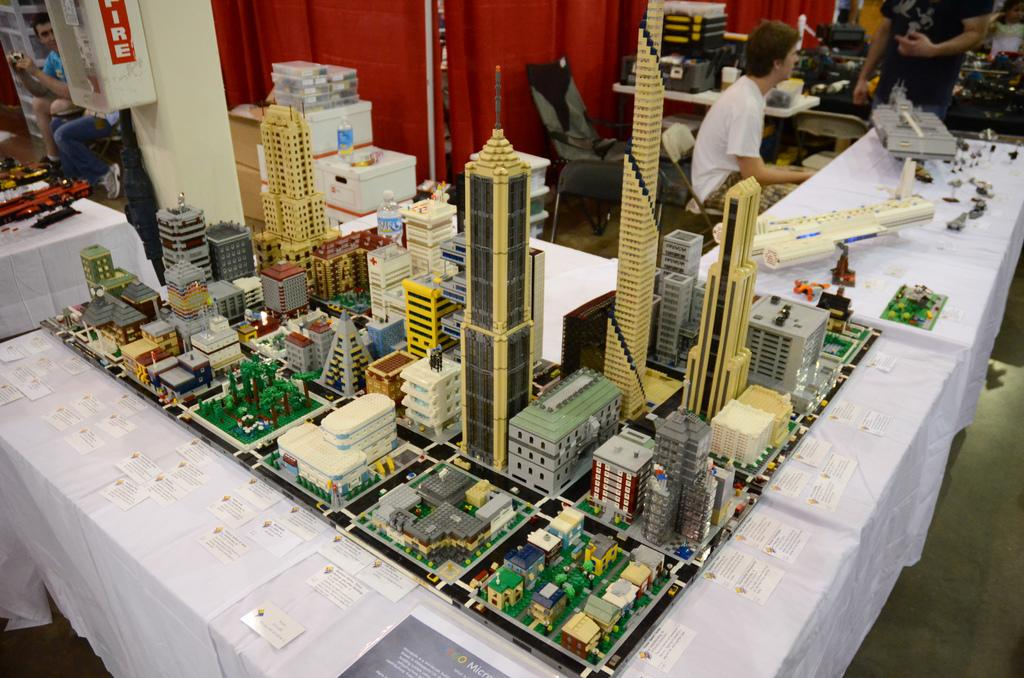What type of furniture is present in the image? There are tables in the image. What is placed on the tables? Model buildings are present on the tables. What can be seen in the background of the image? The background of the image contains white color boxes, chairs, a curtain, and persons. What type of jeans are the persons wearing in the image? There is no information about the type of jeans the persons are wearing in the image, as the focus is on the tables and model buildings. Is there a flame visible in the image? No, there is no flame present in the image. 